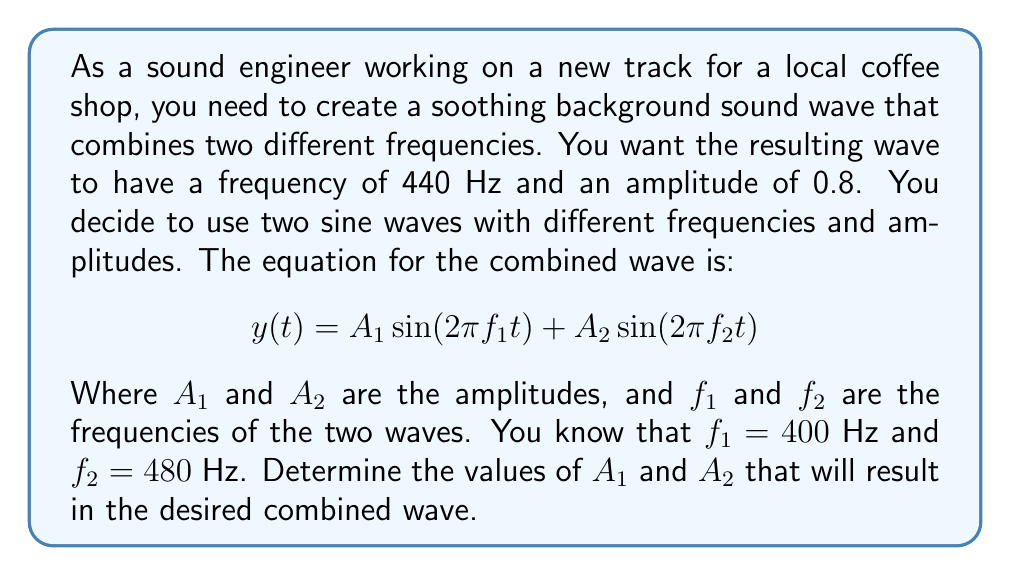Give your solution to this math problem. To solve this problem, we need to use the principles of wave superposition and the given information about the desired frequency and amplitude. Let's approach this step-by-step:

1) The given equation represents the superposition of two sine waves:
   $$y(t) = A_1 \sin(2\pi f_1 t) + A_2 \sin(2\pi f_2 t)$$

2) We're told that $f_1 = 400$ Hz and $f_2 = 480$ Hz. The resulting wave should have a frequency of 440 Hz, which is the average of these two frequencies.

3) The amplitude of the resulting wave is given as 0.8. This is the maximum value of $y(t)$, which occurs when both sine terms reach their maximum value of 1 simultaneously.

4) At this maximum point, we can write:
   $$0.8 = A_1 + A_2$$

5) We need another equation to solve for both $A_1$ and $A_2$. We can use the fact that the power of the resulting wave is proportional to the square of its amplitude, and that power is additive for superposed waves:
   $$(0.8)^2 = A_1^2 + A_2^2$$

6) Now we have a system of two equations with two unknowns:
   $$A_1 + A_2 = 0.8$$
   $$A_1^2 + A_2^2 = 0.64$$

7) We can solve this system by substitution. Let $A_2 = 0.8 - A_1$ from the first equation and substitute into the second:
   $$A_1^2 + (0.8 - A_1)^2 = 0.64$$

8) Expanding:
   $$A_1^2 + 0.64 - 1.6A_1 + A_1^2 = 0.64$$
   $$2A_1^2 - 1.6A_1 = 0$$

9) Factoring out $A_1$:
   $$A_1(2A_1 - 1.6) = 0$$

10) Solving:
    $$A_1 = 0 \text{ or } A_1 = 0.8$$

    The $A_1 = 0$ solution doesn't make sense in this context, so $A_1 = 0.8$.

11) Substituting back:
    $$A_2 = 0.8 - A_1 = 0.8 - 0.8 = 0$$

Therefore, $A_1 = 0.8$ and $A_2 = 0$.
Answer: $A_1 = 0.8$, $A_2 = 0$ 